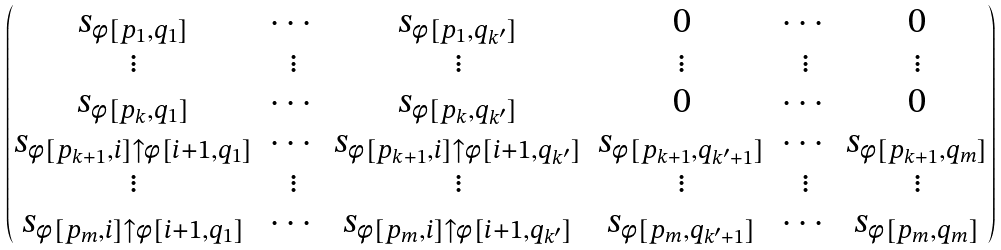<formula> <loc_0><loc_0><loc_500><loc_500>\begin{pmatrix} s _ { \phi [ p _ { 1 } , q _ { 1 } ] } & \cdots & s _ { \phi [ p _ { 1 } , q _ { k ^ { \prime } } ] } & 0 & \cdots & 0 \\ \vdots & \vdots & \vdots & \vdots & \vdots & \vdots \\ s _ { \phi [ p _ { k } , q _ { 1 } ] } & \cdots & s _ { \phi [ p _ { k } , q _ { k ^ { \prime } } ] } & 0 & \cdots & 0 \\ s _ { \phi [ p _ { k + 1 } , i ] \uparrow \phi [ i + 1 , q _ { 1 } ] } & \cdots & s _ { \phi [ p _ { k + 1 } , i ] \uparrow \phi [ i + 1 , q _ { k ^ { \prime } } ] } & s _ { \phi [ p _ { k + 1 } , q _ { k ^ { \prime } + 1 } ] } & \cdots & s _ { \phi [ p _ { k + 1 } , q _ { m } ] } \\ \vdots & \vdots & \vdots & \vdots & \vdots & \vdots \\ s _ { \phi [ p _ { m } , i ] \uparrow \phi [ i + 1 , q _ { 1 } ] } & \cdots & s _ { \phi [ p _ { m } , i ] \uparrow \phi [ i + 1 , q _ { k ^ { \prime } } ] } & s _ { \phi [ p _ { m } , q _ { k ^ { \prime } + 1 } ] } & \cdots & s _ { \phi [ p _ { m } , q _ { m } ] } \end{pmatrix}</formula> 